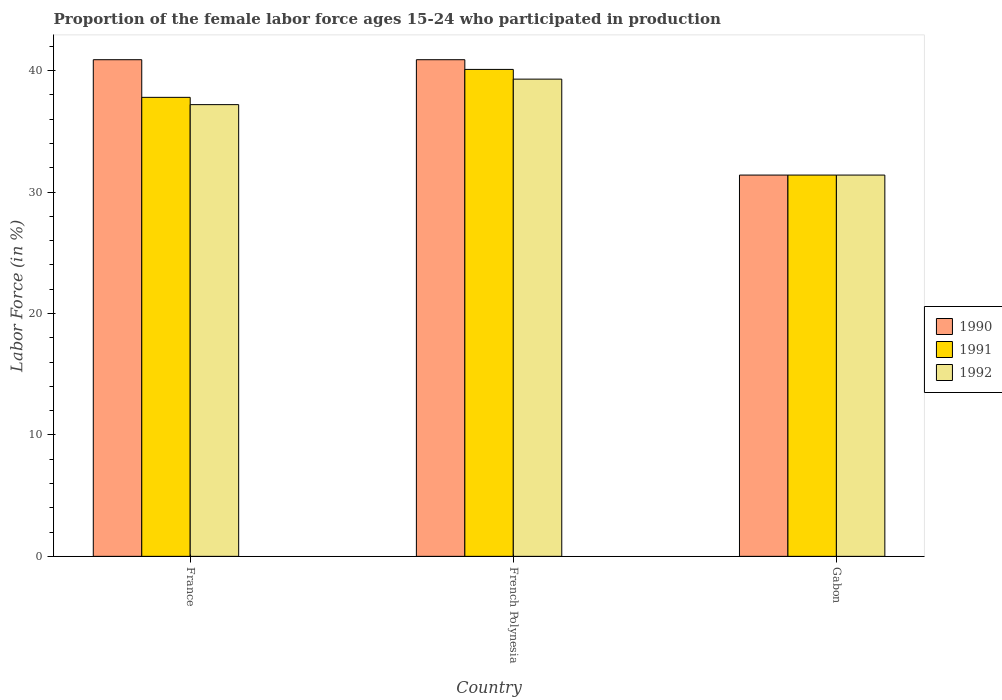Are the number of bars on each tick of the X-axis equal?
Provide a succinct answer. Yes. How many bars are there on the 3rd tick from the left?
Your answer should be compact. 3. How many bars are there on the 1st tick from the right?
Give a very brief answer. 3. What is the proportion of the female labor force who participated in production in 1990 in France?
Offer a terse response. 40.9. Across all countries, what is the maximum proportion of the female labor force who participated in production in 1990?
Provide a short and direct response. 40.9. Across all countries, what is the minimum proportion of the female labor force who participated in production in 1992?
Provide a short and direct response. 31.4. In which country was the proportion of the female labor force who participated in production in 1991 maximum?
Your response must be concise. French Polynesia. In which country was the proportion of the female labor force who participated in production in 1990 minimum?
Your answer should be compact. Gabon. What is the total proportion of the female labor force who participated in production in 1991 in the graph?
Give a very brief answer. 109.3. What is the difference between the proportion of the female labor force who participated in production in 1992 in France and that in French Polynesia?
Give a very brief answer. -2.1. What is the difference between the proportion of the female labor force who participated in production in 1992 in French Polynesia and the proportion of the female labor force who participated in production in 1991 in France?
Provide a short and direct response. 1.5. What is the average proportion of the female labor force who participated in production in 1990 per country?
Your answer should be very brief. 37.73. What is the difference between the proportion of the female labor force who participated in production of/in 1992 and proportion of the female labor force who participated in production of/in 1991 in Gabon?
Your answer should be very brief. 0. In how many countries, is the proportion of the female labor force who participated in production in 1990 greater than 32 %?
Provide a short and direct response. 2. What is the ratio of the proportion of the female labor force who participated in production in 1991 in France to that in Gabon?
Offer a very short reply. 1.2. Is the difference between the proportion of the female labor force who participated in production in 1992 in France and Gabon greater than the difference between the proportion of the female labor force who participated in production in 1991 in France and Gabon?
Offer a very short reply. No. What is the difference between the highest and the second highest proportion of the female labor force who participated in production in 1992?
Make the answer very short. -5.8. What is the difference between the highest and the lowest proportion of the female labor force who participated in production in 1991?
Make the answer very short. 8.7. In how many countries, is the proportion of the female labor force who participated in production in 1991 greater than the average proportion of the female labor force who participated in production in 1991 taken over all countries?
Make the answer very short. 2. Is the sum of the proportion of the female labor force who participated in production in 1991 in France and French Polynesia greater than the maximum proportion of the female labor force who participated in production in 1990 across all countries?
Offer a very short reply. Yes. What does the 2nd bar from the left in French Polynesia represents?
Offer a very short reply. 1991. What does the 2nd bar from the right in Gabon represents?
Keep it short and to the point. 1991. How many bars are there?
Keep it short and to the point. 9. Are all the bars in the graph horizontal?
Give a very brief answer. No. What is the difference between two consecutive major ticks on the Y-axis?
Your answer should be very brief. 10. Does the graph contain grids?
Your response must be concise. No. Where does the legend appear in the graph?
Offer a terse response. Center right. How are the legend labels stacked?
Keep it short and to the point. Vertical. What is the title of the graph?
Make the answer very short. Proportion of the female labor force ages 15-24 who participated in production. What is the Labor Force (in %) of 1990 in France?
Ensure brevity in your answer.  40.9. What is the Labor Force (in %) in 1991 in France?
Give a very brief answer. 37.8. What is the Labor Force (in %) of 1992 in France?
Provide a succinct answer. 37.2. What is the Labor Force (in %) in 1990 in French Polynesia?
Make the answer very short. 40.9. What is the Labor Force (in %) in 1991 in French Polynesia?
Your answer should be very brief. 40.1. What is the Labor Force (in %) of 1992 in French Polynesia?
Your response must be concise. 39.3. What is the Labor Force (in %) in 1990 in Gabon?
Give a very brief answer. 31.4. What is the Labor Force (in %) of 1991 in Gabon?
Offer a very short reply. 31.4. What is the Labor Force (in %) in 1992 in Gabon?
Keep it short and to the point. 31.4. Across all countries, what is the maximum Labor Force (in %) in 1990?
Provide a succinct answer. 40.9. Across all countries, what is the maximum Labor Force (in %) in 1991?
Provide a succinct answer. 40.1. Across all countries, what is the maximum Labor Force (in %) in 1992?
Offer a very short reply. 39.3. Across all countries, what is the minimum Labor Force (in %) of 1990?
Keep it short and to the point. 31.4. Across all countries, what is the minimum Labor Force (in %) in 1991?
Offer a very short reply. 31.4. Across all countries, what is the minimum Labor Force (in %) of 1992?
Provide a short and direct response. 31.4. What is the total Labor Force (in %) of 1990 in the graph?
Your answer should be compact. 113.2. What is the total Labor Force (in %) of 1991 in the graph?
Ensure brevity in your answer.  109.3. What is the total Labor Force (in %) in 1992 in the graph?
Provide a succinct answer. 107.9. What is the difference between the Labor Force (in %) in 1990 in France and that in French Polynesia?
Provide a short and direct response. 0. What is the difference between the Labor Force (in %) of 1991 in French Polynesia and that in Gabon?
Provide a succinct answer. 8.7. What is the difference between the Labor Force (in %) of 1990 in France and the Labor Force (in %) of 1991 in French Polynesia?
Ensure brevity in your answer.  0.8. What is the difference between the Labor Force (in %) of 1991 in France and the Labor Force (in %) of 1992 in Gabon?
Your answer should be compact. 6.4. What is the difference between the Labor Force (in %) in 1990 in French Polynesia and the Labor Force (in %) in 1992 in Gabon?
Your response must be concise. 9.5. What is the difference between the Labor Force (in %) in 1991 in French Polynesia and the Labor Force (in %) in 1992 in Gabon?
Your response must be concise. 8.7. What is the average Labor Force (in %) of 1990 per country?
Keep it short and to the point. 37.73. What is the average Labor Force (in %) in 1991 per country?
Provide a short and direct response. 36.43. What is the average Labor Force (in %) of 1992 per country?
Offer a very short reply. 35.97. What is the difference between the Labor Force (in %) in 1990 and Labor Force (in %) in 1992 in France?
Provide a succinct answer. 3.7. What is the difference between the Labor Force (in %) of 1990 and Labor Force (in %) of 1991 in French Polynesia?
Make the answer very short. 0.8. What is the difference between the Labor Force (in %) of 1990 and Labor Force (in %) of 1991 in Gabon?
Ensure brevity in your answer.  0. What is the difference between the Labor Force (in %) in 1990 and Labor Force (in %) in 1992 in Gabon?
Keep it short and to the point. 0. What is the difference between the Labor Force (in %) in 1991 and Labor Force (in %) in 1992 in Gabon?
Provide a short and direct response. 0. What is the ratio of the Labor Force (in %) of 1990 in France to that in French Polynesia?
Give a very brief answer. 1. What is the ratio of the Labor Force (in %) of 1991 in France to that in French Polynesia?
Offer a very short reply. 0.94. What is the ratio of the Labor Force (in %) in 1992 in France to that in French Polynesia?
Make the answer very short. 0.95. What is the ratio of the Labor Force (in %) in 1990 in France to that in Gabon?
Ensure brevity in your answer.  1.3. What is the ratio of the Labor Force (in %) in 1991 in France to that in Gabon?
Give a very brief answer. 1.2. What is the ratio of the Labor Force (in %) of 1992 in France to that in Gabon?
Keep it short and to the point. 1.18. What is the ratio of the Labor Force (in %) in 1990 in French Polynesia to that in Gabon?
Your response must be concise. 1.3. What is the ratio of the Labor Force (in %) of 1991 in French Polynesia to that in Gabon?
Make the answer very short. 1.28. What is the ratio of the Labor Force (in %) in 1992 in French Polynesia to that in Gabon?
Keep it short and to the point. 1.25. What is the difference between the highest and the second highest Labor Force (in %) in 1990?
Keep it short and to the point. 0. What is the difference between the highest and the second highest Labor Force (in %) in 1991?
Ensure brevity in your answer.  2.3. What is the difference between the highest and the lowest Labor Force (in %) in 1992?
Ensure brevity in your answer.  7.9. 